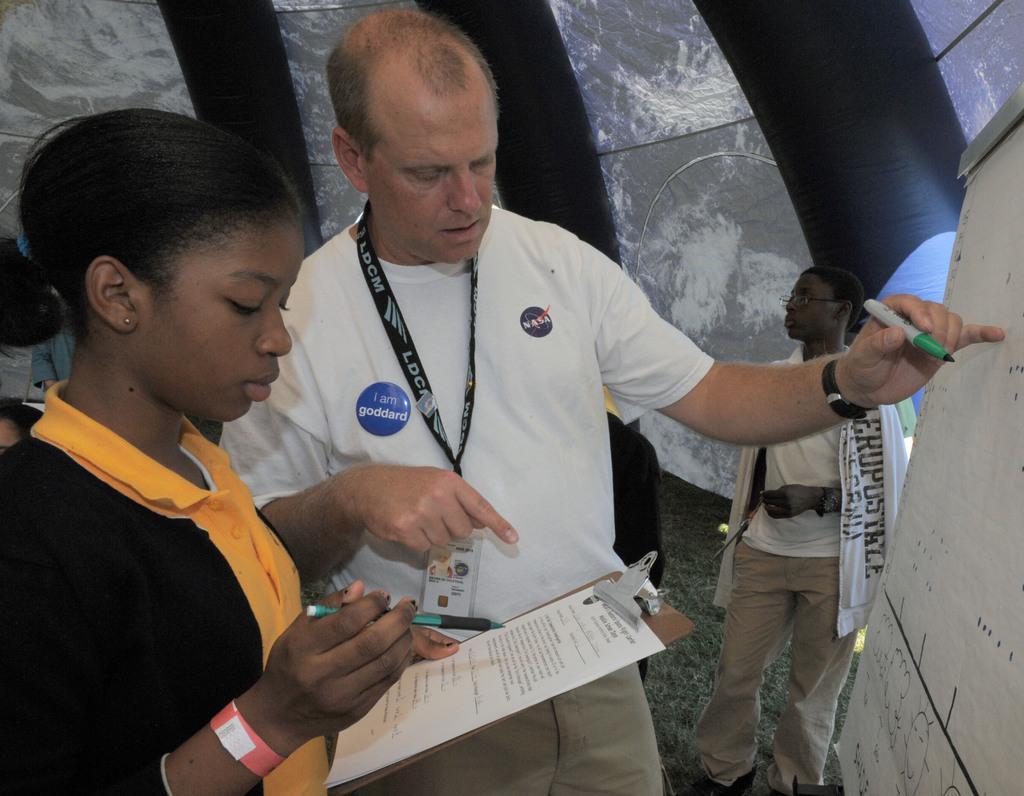Please provide a concise description of this image. This image consists of three persons. One is holding exam pad. Another one is writing something on the board. 